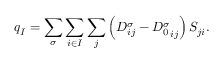Convert formula to latex. <formula><loc_0><loc_0><loc_500><loc_500>q _ { I } = \sum _ { \sigma } \sum _ { i \in I } \sum _ { j } \left ( D _ { i j } ^ { \sigma } - { D _ { 0 } ^ { \sigma } } _ { i j } \right ) S _ { j i } .</formula> 